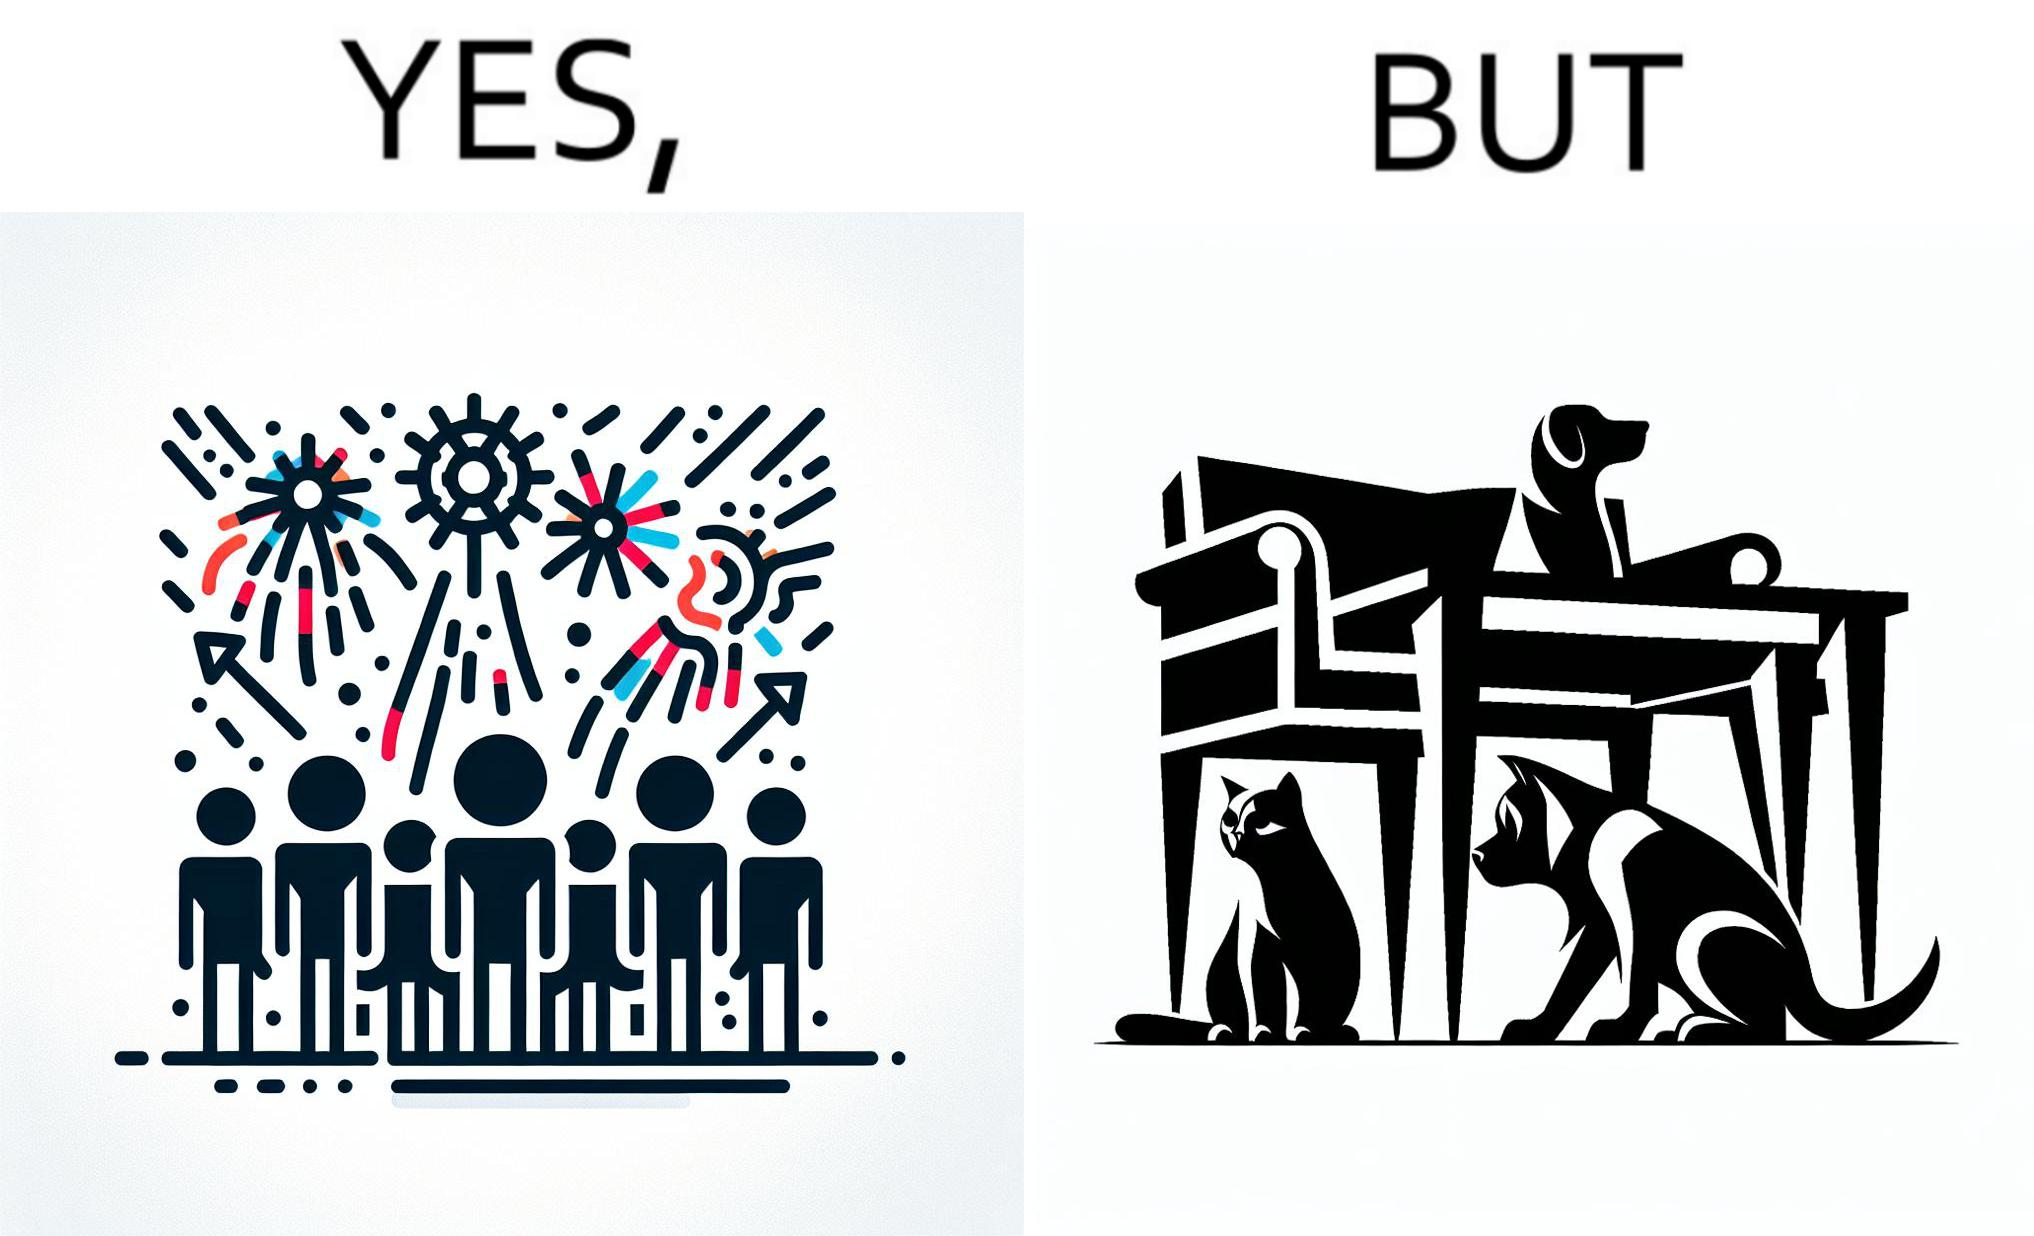What is shown in this image? The image is satirical because while firecrackers in the sky look pretty, not everyone likes them. Animals are very scared of the firecrackers. 